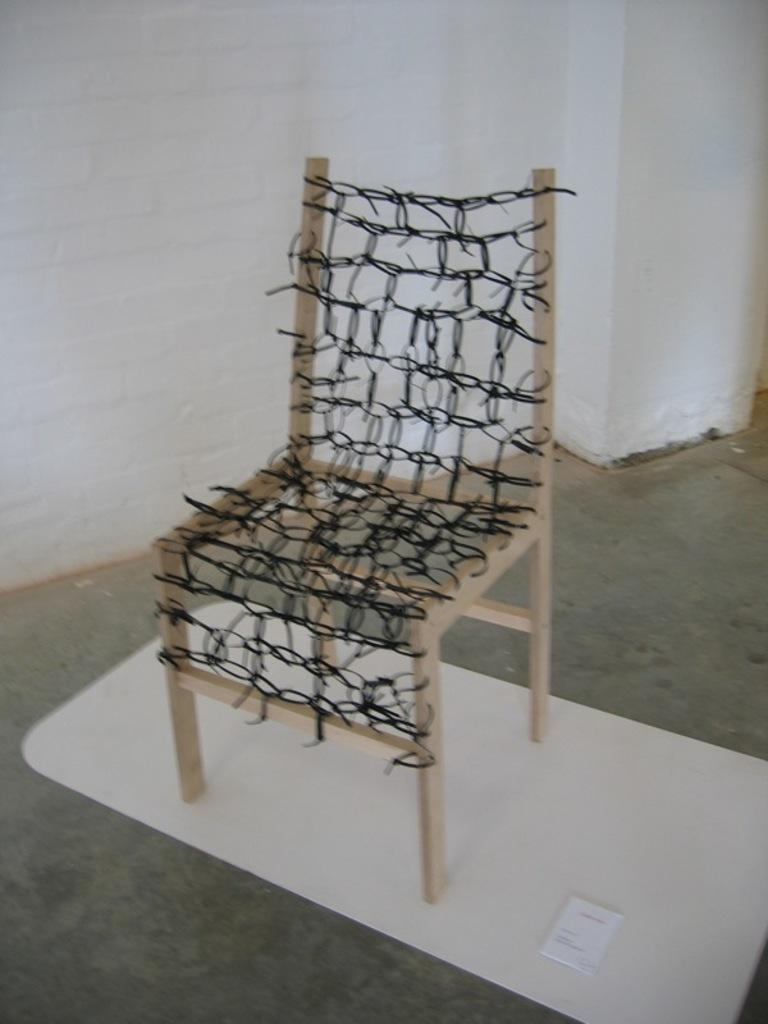What type of furniture is present in the image? There is a chair in the image. Where is the chair located? The chair is on the floor. What can be seen in the background of the image? There is a wall visible in the background of the image. Can you see a boat in the image? No, there is no boat present in the image. What type of jewelry is visible on the chair? There is no jewelry, such as a locket, present in the image. 